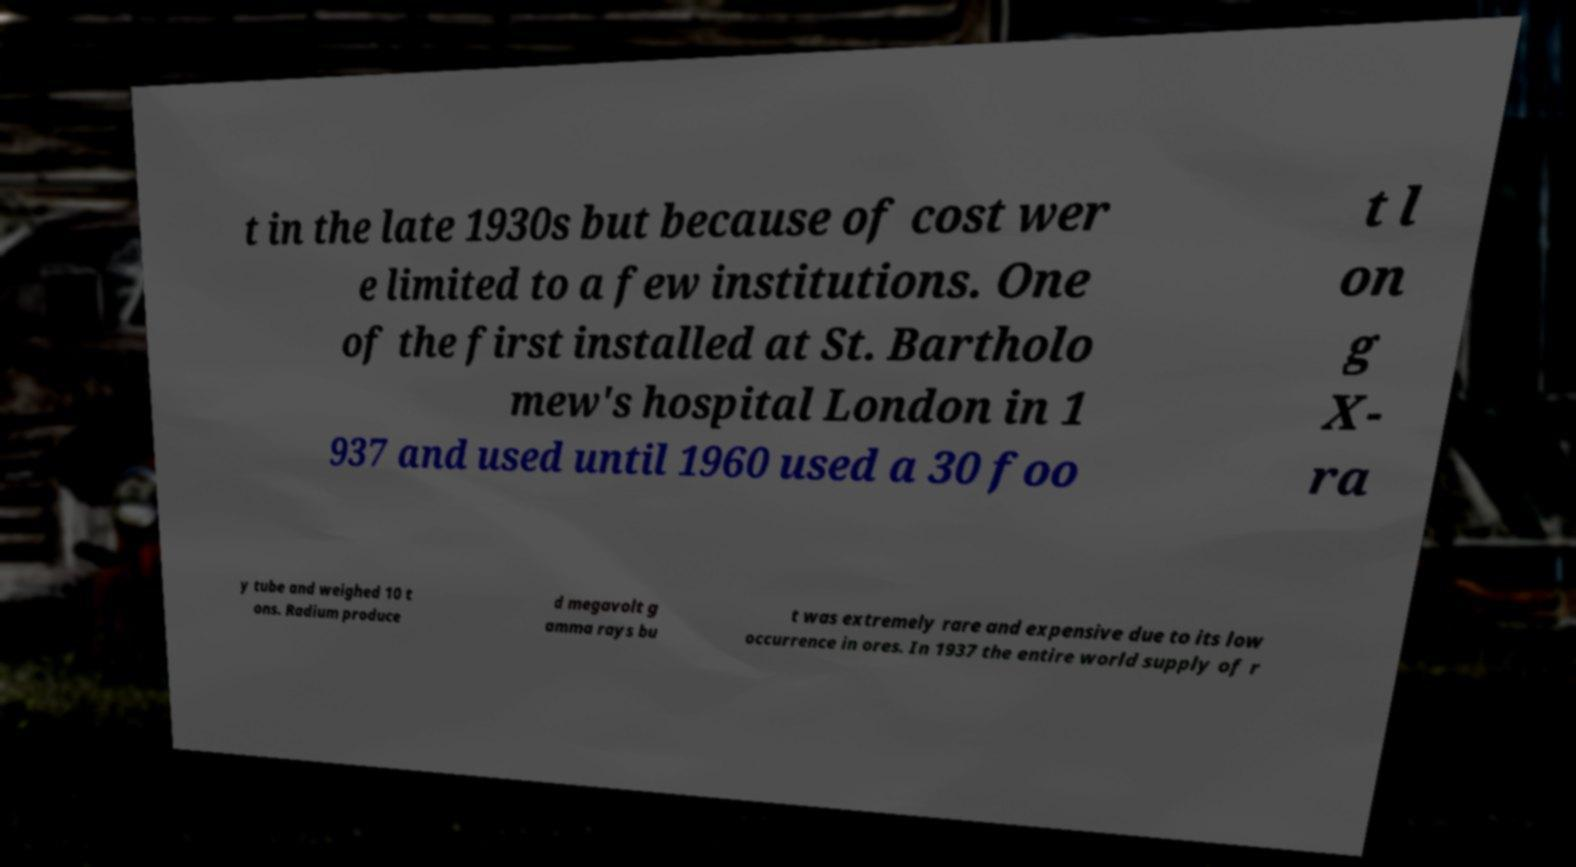What messages or text are displayed in this image? I need them in a readable, typed format. t in the late 1930s but because of cost wer e limited to a few institutions. One of the first installed at St. Bartholo mew's hospital London in 1 937 and used until 1960 used a 30 foo t l on g X- ra y tube and weighed 10 t ons. Radium produce d megavolt g amma rays bu t was extremely rare and expensive due to its low occurrence in ores. In 1937 the entire world supply of r 